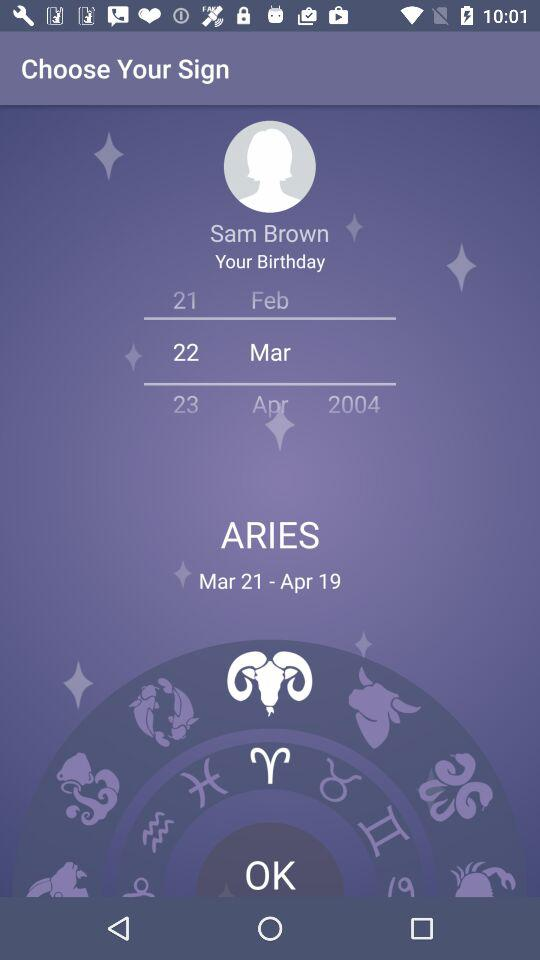What is the user name? The user name is Sam Brown. 